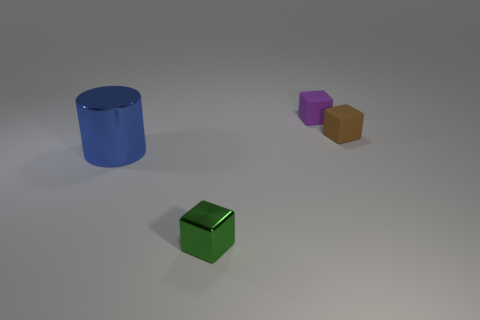Subtract all small matte blocks. How many blocks are left? 1 Subtract all purple cubes. How many cubes are left? 2 Add 2 small objects. How many objects exist? 6 Subtract all purple spheres. How many green cubes are left? 1 Subtract all large cyan matte cylinders. Subtract all brown matte cubes. How many objects are left? 3 Add 3 things. How many things are left? 7 Add 3 small matte things. How many small matte things exist? 5 Subtract 0 cyan blocks. How many objects are left? 4 Subtract all cylinders. How many objects are left? 3 Subtract all green blocks. Subtract all gray cylinders. How many blocks are left? 2 